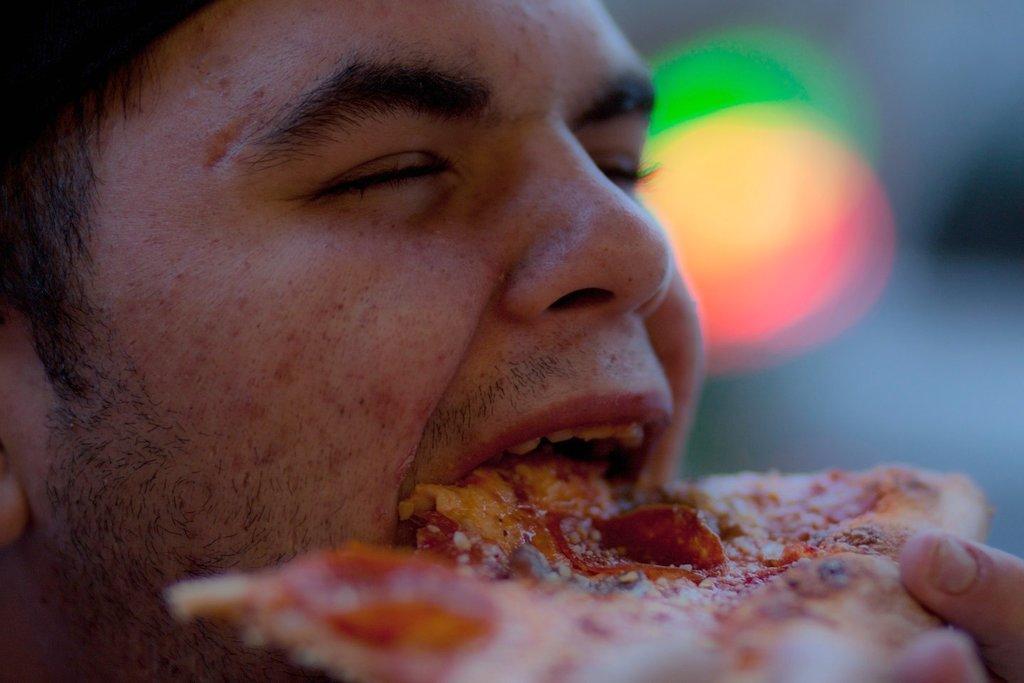Can you describe this image briefly? In the center of the image there is a person eating food. 